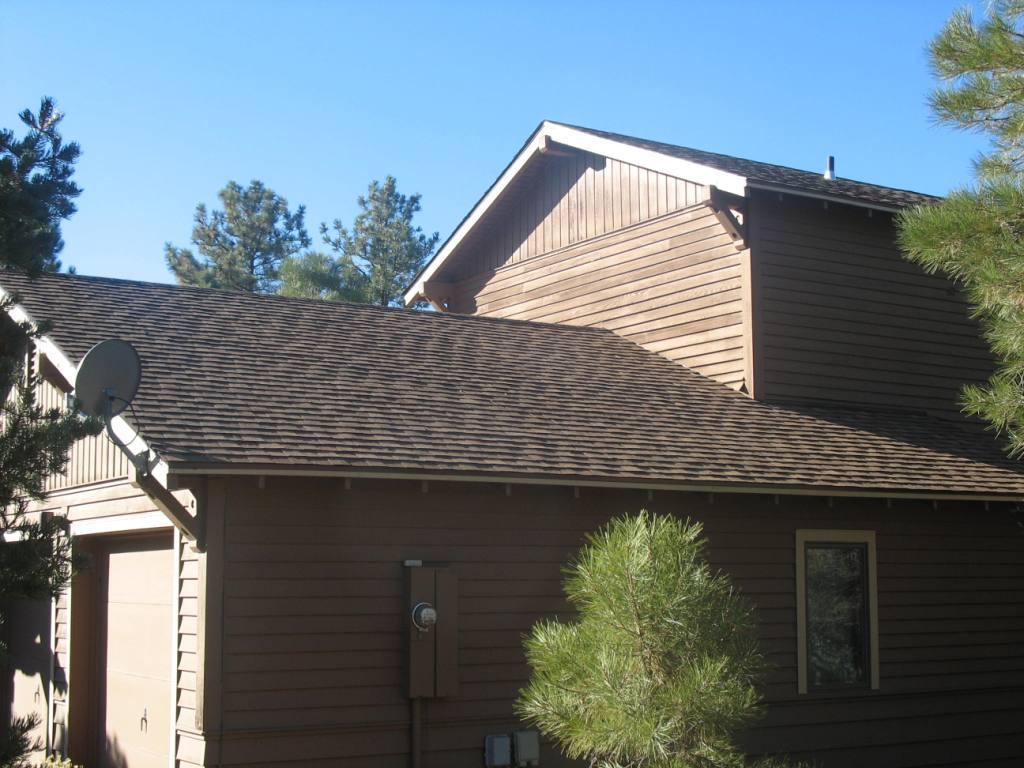Please provide a concise description of this image. In the image we can see there are trees and there are buildings. There is a dish tv antenna kept on the roof of the building. The sky is clear. 